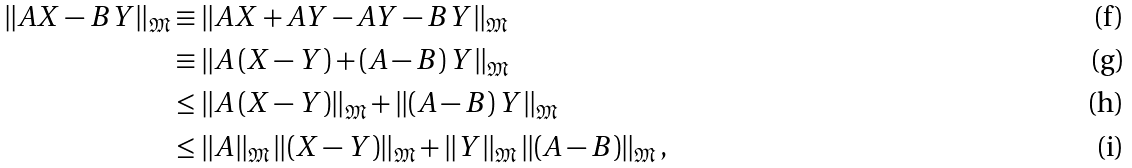Convert formula to latex. <formula><loc_0><loc_0><loc_500><loc_500>\left \| { A } { X } - { B } { Y } \right \| _ { \mathfrak { M } } & \equiv \left \| { A } { X } + { A } { Y } - { A } { Y } - { B } { Y } \right \| _ { \mathfrak { M } } \\ & \equiv \left \| { A } \left ( { X } - { Y } \right ) + \left ( { A } - { B } \right ) { Y } \right \| _ { \mathfrak { M } } \\ & \leq \left \| { A } \left ( { X } - { Y } \right ) \right \| _ { \mathfrak { M } } + \left \| \left ( { A } - { B } \right ) { Y } \right \| _ { \mathfrak { M } } \\ & \leq \left \| { A } \right \| _ { \mathfrak { M } } \left \| \left ( { X } - { Y } \right ) \right \| _ { \mathfrak { M } } + \left \| { Y } \right \| _ { \mathfrak { M } } \left \| \left ( { A } - { B } \right ) \right \| _ { \mathfrak { M } } ,</formula> 